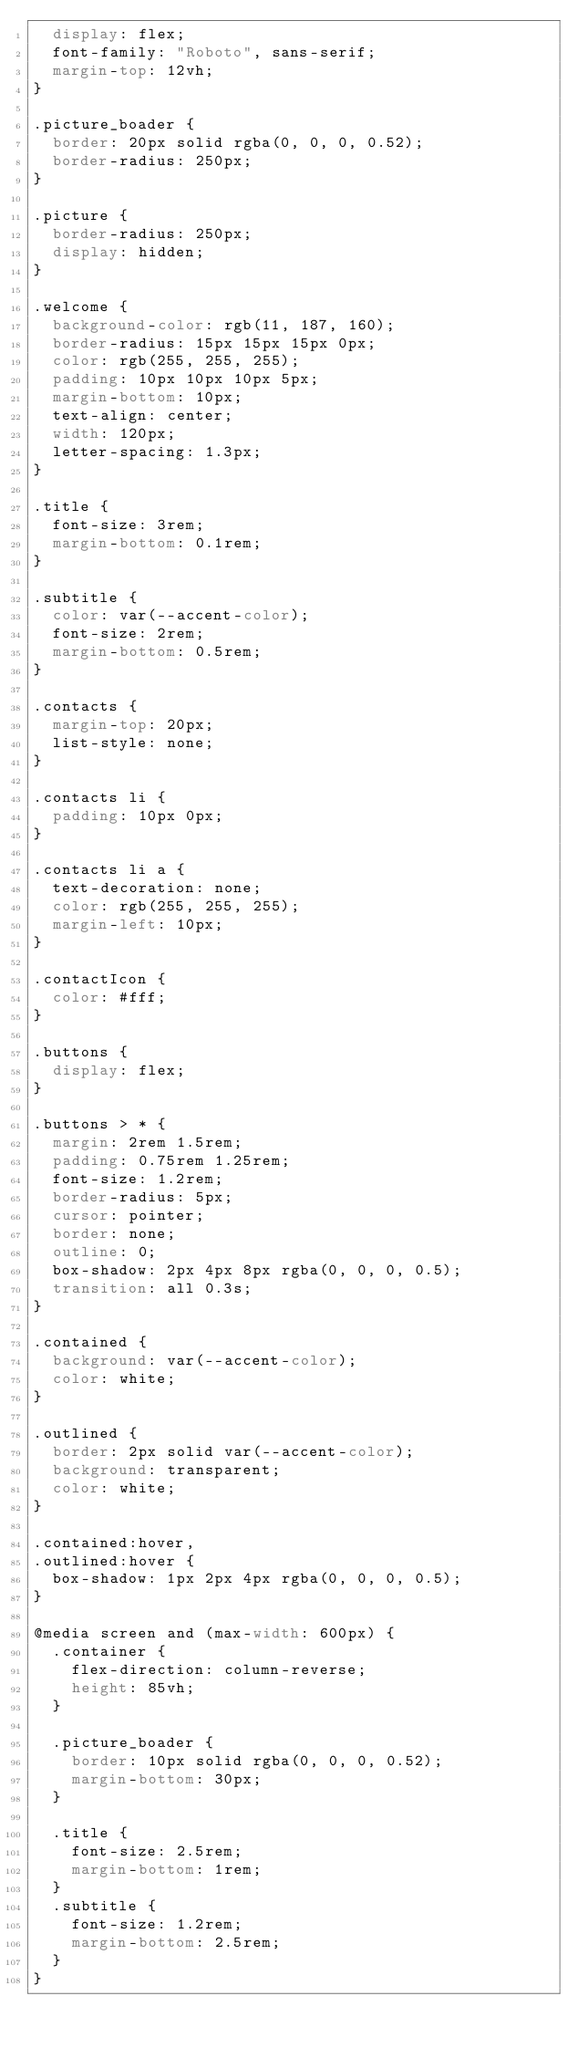<code> <loc_0><loc_0><loc_500><loc_500><_CSS_>  display: flex;
  font-family: "Roboto", sans-serif;
  margin-top: 12vh;
}

.picture_boader {
  border: 20px solid rgba(0, 0, 0, 0.52);
  border-radius: 250px;
}

.picture {
  border-radius: 250px;
  display: hidden;
}

.welcome {
  background-color: rgb(11, 187, 160);
  border-radius: 15px 15px 15px 0px;
  color: rgb(255, 255, 255);
  padding: 10px 10px 10px 5px;
  margin-bottom: 10px;
  text-align: center;
  width: 120px;
  letter-spacing: 1.3px;
}

.title {
  font-size: 3rem;
  margin-bottom: 0.1rem;
}

.subtitle {
  color: var(--accent-color);
  font-size: 2rem;
  margin-bottom: 0.5rem;
}

.contacts {
  margin-top: 20px;
  list-style: none;
}

.contacts li {
  padding: 10px 0px;
}

.contacts li a {
  text-decoration: none;
  color: rgb(255, 255, 255);
  margin-left: 10px;
}

.contactIcon {
  color: #fff;
}

.buttons {
  display: flex;
}

.buttons > * {
  margin: 2rem 1.5rem;
  padding: 0.75rem 1.25rem;
  font-size: 1.2rem;
  border-radius: 5px;
  cursor: pointer;
  border: none;
  outline: 0;
  box-shadow: 2px 4px 8px rgba(0, 0, 0, 0.5);
  transition: all 0.3s;
}

.contained {
  background: var(--accent-color);
  color: white;
}

.outlined {
  border: 2px solid var(--accent-color);
  background: transparent;
  color: white;
}

.contained:hover,
.outlined:hover {
  box-shadow: 1px 2px 4px rgba(0, 0, 0, 0.5);
}

@media screen and (max-width: 600px) {
  .container {
    flex-direction: column-reverse;
    height: 85vh;
  }

  .picture_boader {
    border: 10px solid rgba(0, 0, 0, 0.52);
    margin-bottom: 30px;
  }

  .title {
    font-size: 2.5rem;
    margin-bottom: 1rem;
  }
  .subtitle {
    font-size: 1.2rem;
    margin-bottom: 2.5rem;
  }
}
</code> 